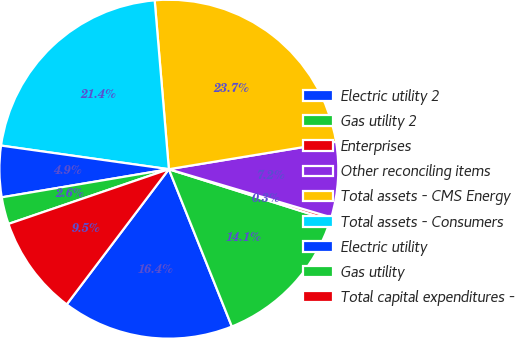Convert chart to OTSL. <chart><loc_0><loc_0><loc_500><loc_500><pie_chart><fcel>Electric utility 2<fcel>Gas utility 2<fcel>Enterprises<fcel>Other reconciling items<fcel>Total assets - CMS Energy<fcel>Total assets - Consumers<fcel>Electric utility<fcel>Gas utility<fcel>Total capital expenditures -<nl><fcel>16.36%<fcel>14.06%<fcel>0.29%<fcel>7.18%<fcel>23.74%<fcel>21.44%<fcel>4.88%<fcel>2.58%<fcel>9.47%<nl></chart> 